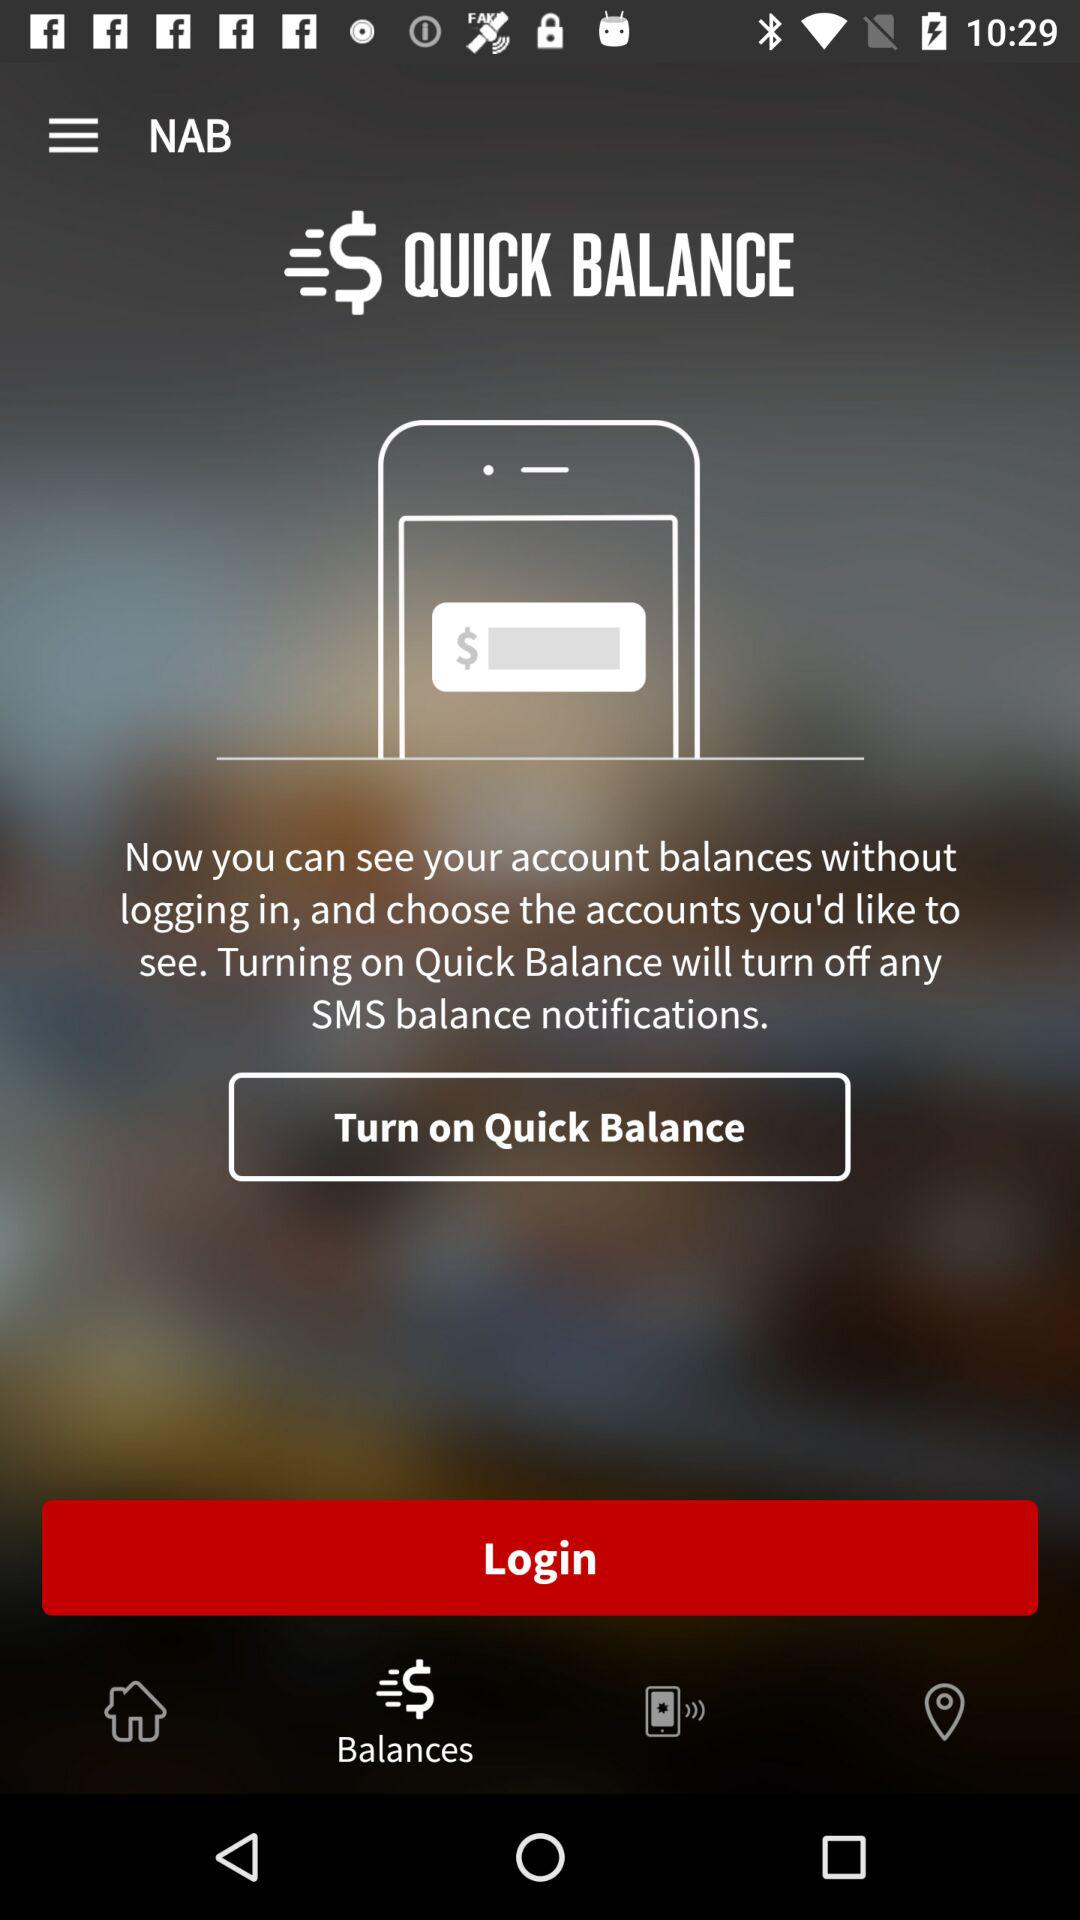Which tab is selected? The selected tab is "Balances". 